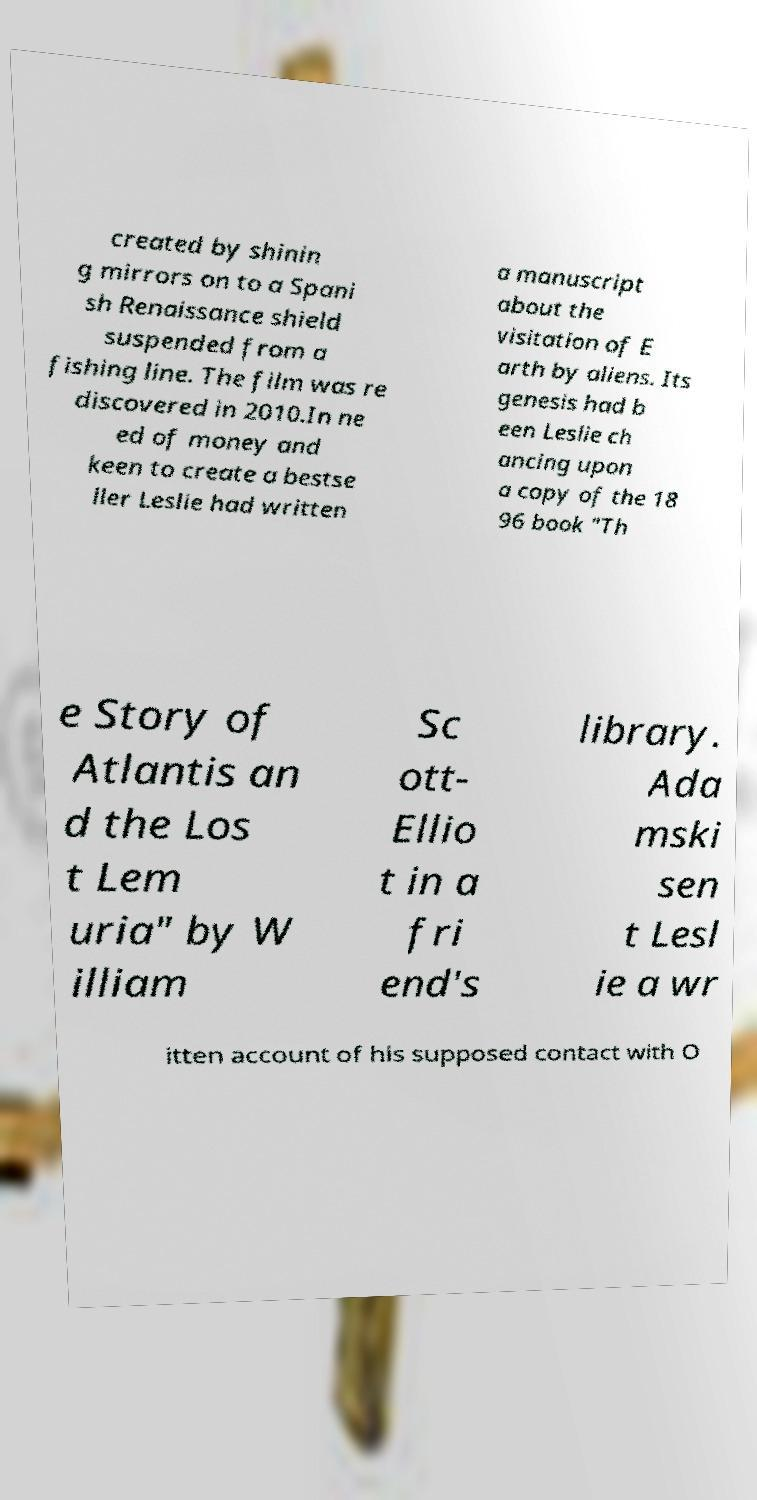Can you read and provide the text displayed in the image?This photo seems to have some interesting text. Can you extract and type it out for me? created by shinin g mirrors on to a Spani sh Renaissance shield suspended from a fishing line. The film was re discovered in 2010.In ne ed of money and keen to create a bestse ller Leslie had written a manuscript about the visitation of E arth by aliens. Its genesis had b een Leslie ch ancing upon a copy of the 18 96 book "Th e Story of Atlantis an d the Los t Lem uria" by W illiam Sc ott- Ellio t in a fri end's library. Ada mski sen t Lesl ie a wr itten account of his supposed contact with O 